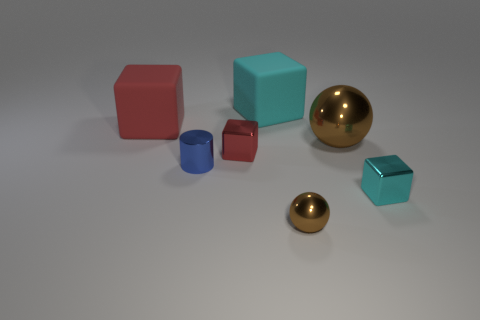Subtract all red blocks. How many were subtracted if there are1red blocks left? 1 Subtract 1 blocks. How many blocks are left? 3 Add 2 big brown objects. How many objects exist? 9 Subtract all spheres. How many objects are left? 5 Add 1 small rubber objects. How many small rubber objects exist? 1 Subtract 0 cyan cylinders. How many objects are left? 7 Subtract all big red spheres. Subtract all spheres. How many objects are left? 5 Add 1 brown shiny balls. How many brown shiny balls are left? 3 